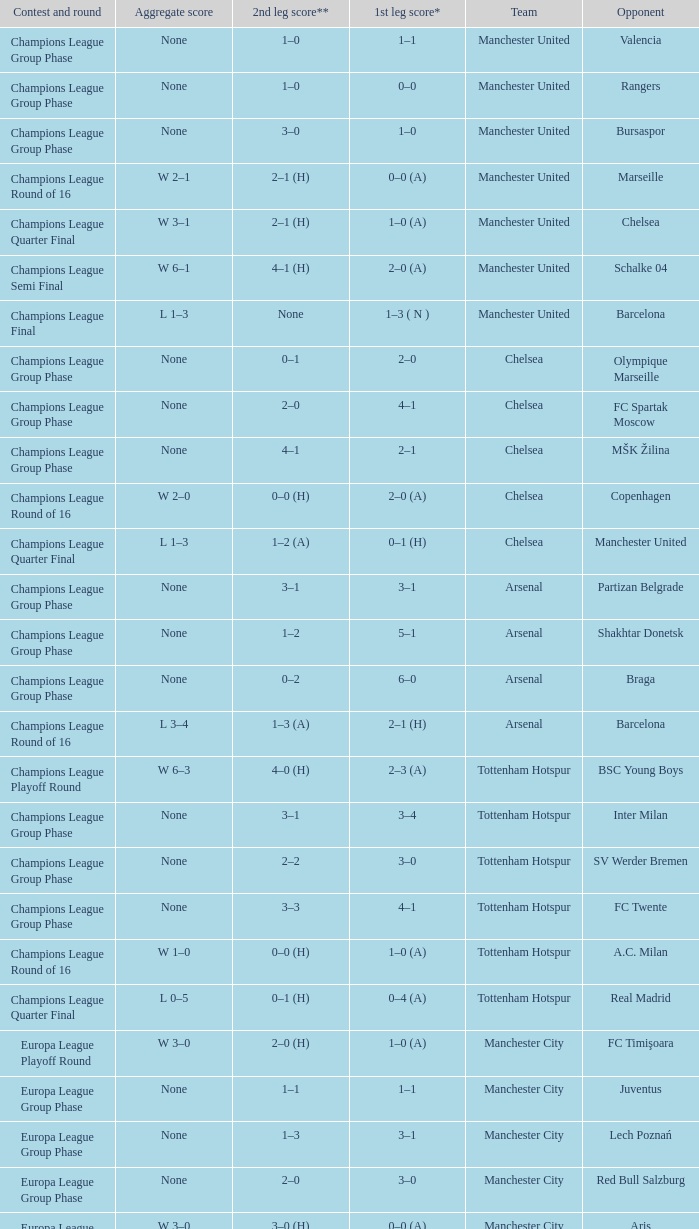How many goals did each one of the teams score in the first leg of the match between Liverpool and Trabzonspor? 1–0 (H). 